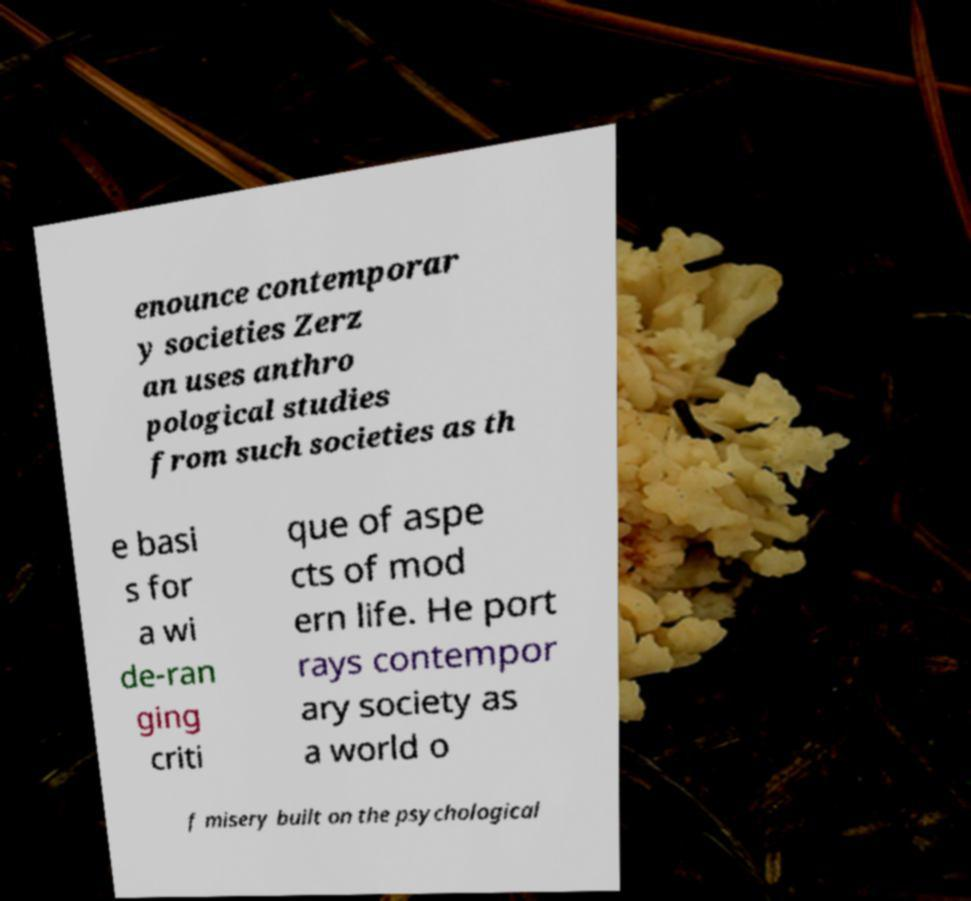Could you assist in decoding the text presented in this image and type it out clearly? enounce contemporar y societies Zerz an uses anthro pological studies from such societies as th e basi s for a wi de-ran ging criti que of aspe cts of mod ern life. He port rays contempor ary society as a world o f misery built on the psychological 